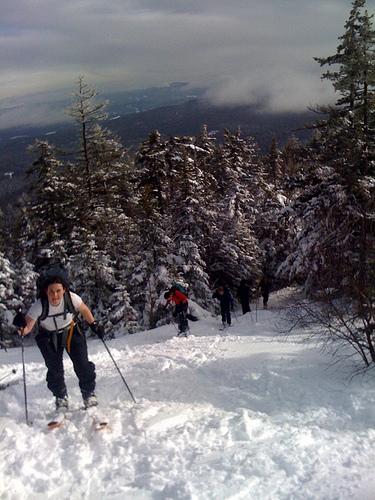How many skies are there?
Be succinct. 5. Are they skiing uphill?
Quick response, please. Yes. Is the girl dressed for the weather?
Write a very short answer. No. What kind of weather is this?
Answer briefly. Snow. Does it look like it is going to snow?
Be succinct. Yes. 